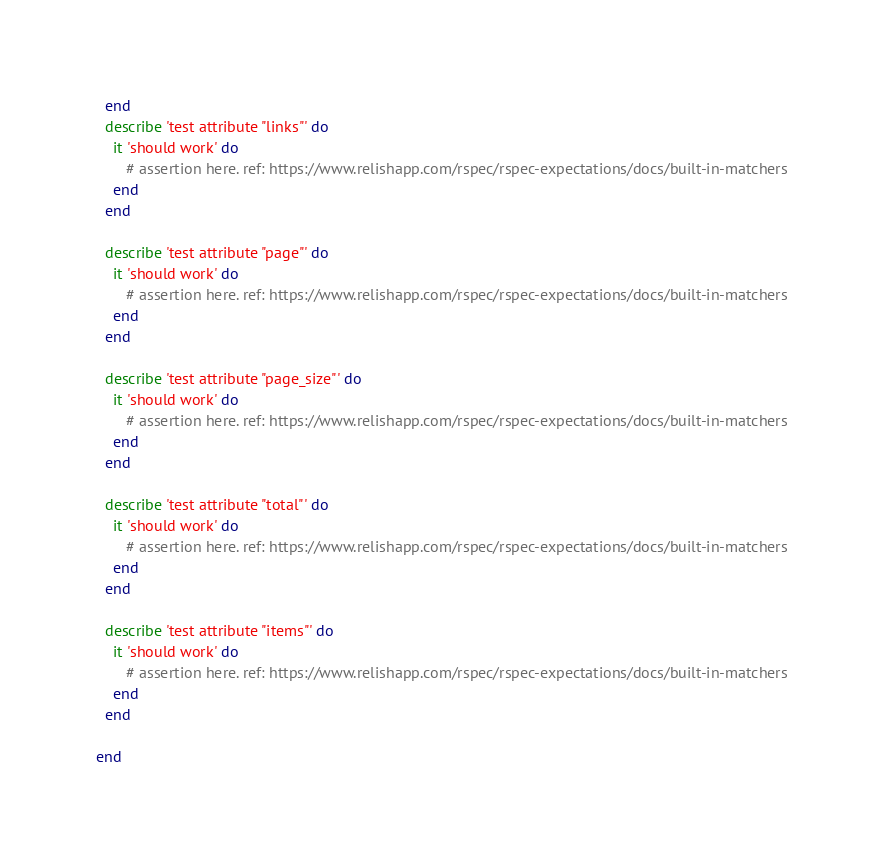Convert code to text. <code><loc_0><loc_0><loc_500><loc_500><_Ruby_>  end
  describe 'test attribute "links"' do
    it 'should work' do
       # assertion here. ref: https://www.relishapp.com/rspec/rspec-expectations/docs/built-in-matchers
    end
  end

  describe 'test attribute "page"' do
    it 'should work' do
       # assertion here. ref: https://www.relishapp.com/rspec/rspec-expectations/docs/built-in-matchers
    end
  end

  describe 'test attribute "page_size"' do
    it 'should work' do
       # assertion here. ref: https://www.relishapp.com/rspec/rspec-expectations/docs/built-in-matchers
    end
  end

  describe 'test attribute "total"' do
    it 'should work' do
       # assertion here. ref: https://www.relishapp.com/rspec/rspec-expectations/docs/built-in-matchers
    end
  end

  describe 'test attribute "items"' do
    it 'should work' do
       # assertion here. ref: https://www.relishapp.com/rspec/rspec-expectations/docs/built-in-matchers
    end
  end

end

</code> 